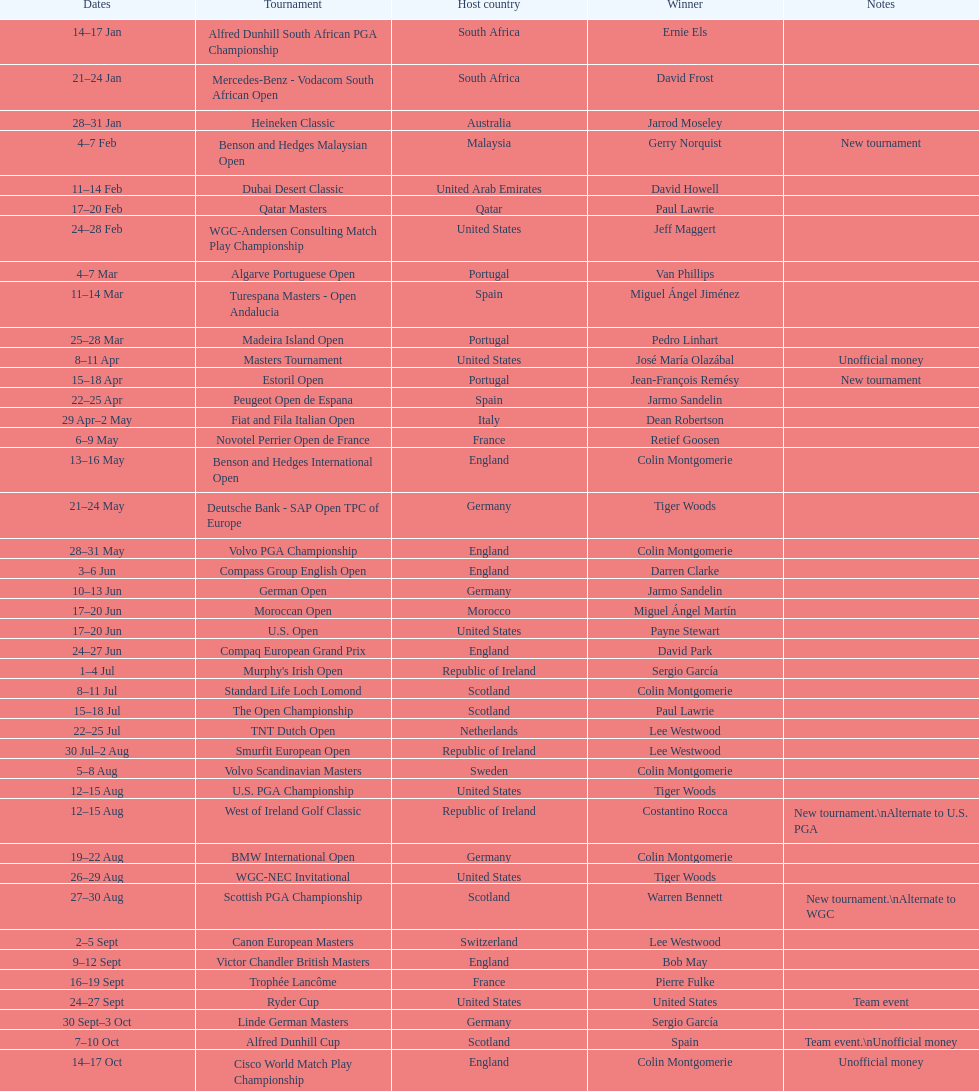What was the country listed the first time there was a new tournament? Malaysia. 